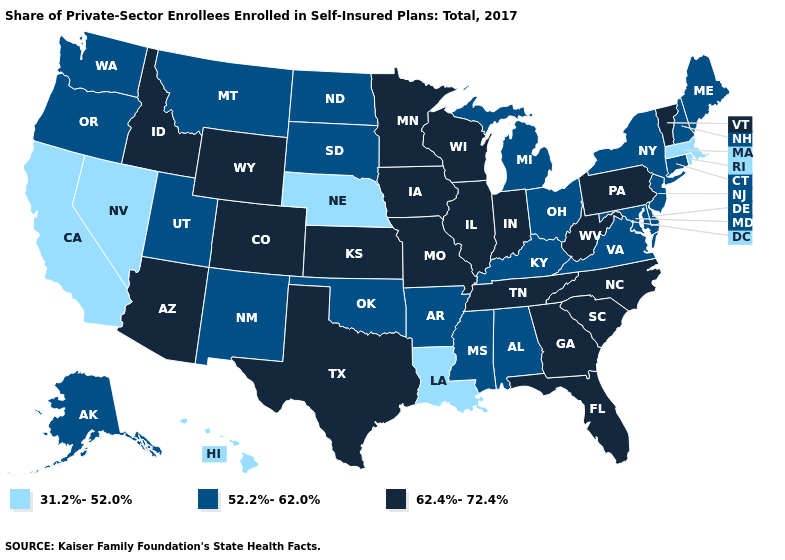What is the highest value in the USA?
Answer briefly. 62.4%-72.4%. Which states have the lowest value in the West?
Short answer required. California, Hawaii, Nevada. What is the highest value in states that border South Carolina?
Be succinct. 62.4%-72.4%. What is the value of California?
Short answer required. 31.2%-52.0%. How many symbols are there in the legend?
Give a very brief answer. 3. Which states have the highest value in the USA?
Write a very short answer. Arizona, Colorado, Florida, Georgia, Idaho, Illinois, Indiana, Iowa, Kansas, Minnesota, Missouri, North Carolina, Pennsylvania, South Carolina, Tennessee, Texas, Vermont, West Virginia, Wisconsin, Wyoming. Which states have the highest value in the USA?
Write a very short answer. Arizona, Colorado, Florida, Georgia, Idaho, Illinois, Indiana, Iowa, Kansas, Minnesota, Missouri, North Carolina, Pennsylvania, South Carolina, Tennessee, Texas, Vermont, West Virginia, Wisconsin, Wyoming. Does the first symbol in the legend represent the smallest category?
Give a very brief answer. Yes. Does Wyoming have the highest value in the West?
Be succinct. Yes. Which states hav the highest value in the West?
Give a very brief answer. Arizona, Colorado, Idaho, Wyoming. Does Nebraska have the lowest value in the USA?
Write a very short answer. Yes. Which states have the highest value in the USA?
Short answer required. Arizona, Colorado, Florida, Georgia, Idaho, Illinois, Indiana, Iowa, Kansas, Minnesota, Missouri, North Carolina, Pennsylvania, South Carolina, Tennessee, Texas, Vermont, West Virginia, Wisconsin, Wyoming. How many symbols are there in the legend?
Short answer required. 3. Does Texas have the same value as Wyoming?
Concise answer only. Yes. What is the value of Alaska?
Concise answer only. 52.2%-62.0%. 